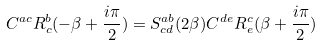Convert formula to latex. <formula><loc_0><loc_0><loc_500><loc_500>C ^ { a c } R ^ { b } _ { c } ( - \beta + \frac { i \pi } { 2 } ) = { S } ^ { a b } _ { c d } ( 2 \beta ) C ^ { d e } R ^ { c } _ { e } ( \beta + \frac { i \pi } { 2 } )</formula> 